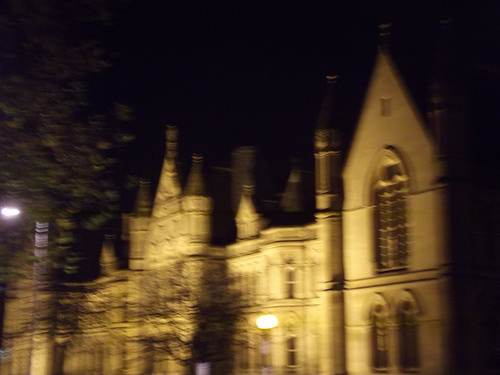<image>
Is there a street lamp in front of the cathedral? Yes. The street lamp is positioned in front of the cathedral, appearing closer to the camera viewpoint. 